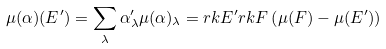<formula> <loc_0><loc_0><loc_500><loc_500>\mu ( \alpha ) ( E ^ { \prime } ) = \sum _ { \lambda } \alpha ^ { \prime } _ { \lambda } \mu ( \alpha ) _ { \lambda } = r k E ^ { \prime } r k F \left ( \mu ( F ) - \mu ( E ^ { \prime } ) \right )</formula> 